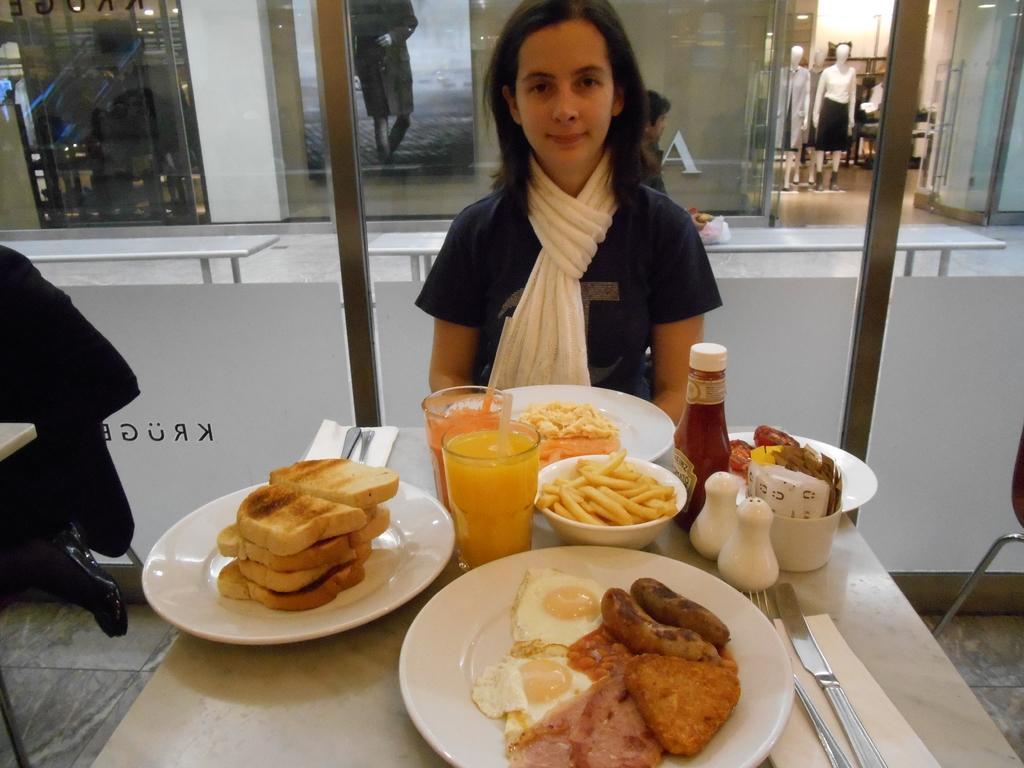Please provide a concise description of this image. Here we can see a woman. This is table. On the table there are plates, glasses, bowl, bottles, spoons, forks, and food. This is floor and there is a chair. In the background we can see glasses, poster, and mannequins. 